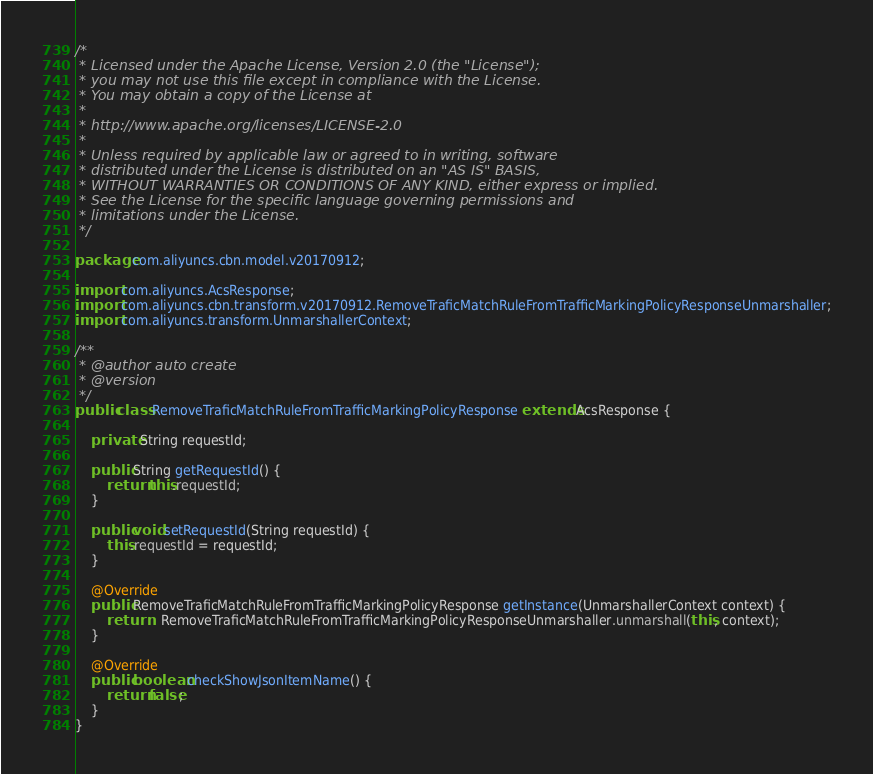Convert code to text. <code><loc_0><loc_0><loc_500><loc_500><_Java_>/*
 * Licensed under the Apache License, Version 2.0 (the "License");
 * you may not use this file except in compliance with the License.
 * You may obtain a copy of the License at
 *
 * http://www.apache.org/licenses/LICENSE-2.0
 *
 * Unless required by applicable law or agreed to in writing, software
 * distributed under the License is distributed on an "AS IS" BASIS,
 * WITHOUT WARRANTIES OR CONDITIONS OF ANY KIND, either express or implied.
 * See the License for the specific language governing permissions and
 * limitations under the License.
 */

package com.aliyuncs.cbn.model.v20170912;

import com.aliyuncs.AcsResponse;
import com.aliyuncs.cbn.transform.v20170912.RemoveTraficMatchRuleFromTrafficMarkingPolicyResponseUnmarshaller;
import com.aliyuncs.transform.UnmarshallerContext;

/**
 * @author auto create
 * @version 
 */
public class RemoveTraficMatchRuleFromTrafficMarkingPolicyResponse extends AcsResponse {

	private String requestId;

	public String getRequestId() {
		return this.requestId;
	}

	public void setRequestId(String requestId) {
		this.requestId = requestId;
	}

	@Override
	public RemoveTraficMatchRuleFromTrafficMarkingPolicyResponse getInstance(UnmarshallerContext context) {
		return	RemoveTraficMatchRuleFromTrafficMarkingPolicyResponseUnmarshaller.unmarshall(this, context);
	}

	@Override
	public boolean checkShowJsonItemName() {
		return false;
	}
}
</code> 